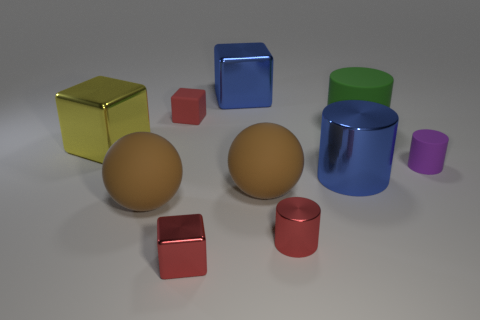Subtract 1 blocks. How many blocks are left? 3 Subtract all cubes. How many objects are left? 6 Add 4 big things. How many big things are left? 10 Add 8 green shiny things. How many green shiny things exist? 8 Subtract 0 purple balls. How many objects are left? 10 Subtract all red shiny cylinders. Subtract all blue metallic things. How many objects are left? 7 